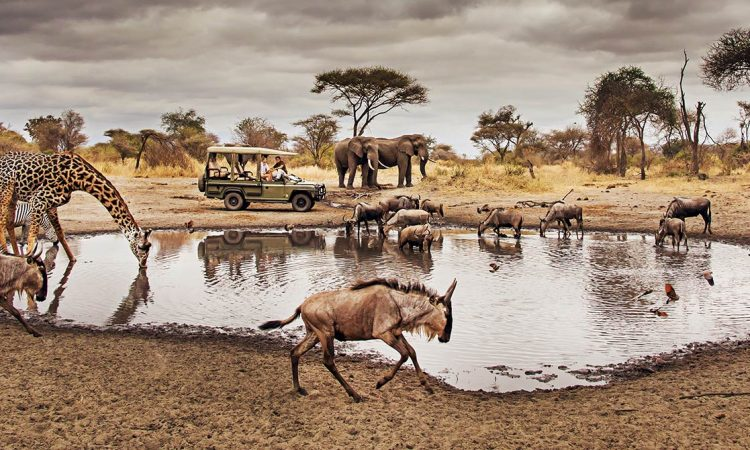Write a detailed description of the given image. This image captures a serene yet dynamic moment during a safari tour at the Serengeti National Park in Tanzania. The perspective is low, offering a ground-level view that makes the observer feel embedded in the scene. In the foreground, a variety of African wildlife gathers around a watering hole, an essential resource for their survival. A giraffe, towering as one of the tallest animals on Earth, seems curious about a nearby safari vehicle filled with tourists, possibly capturing the moment with cameras. To the left, a group of wildebeests is seen drinking water, their reflections shimmering on the surface of the watering hole. In the background, a couple of majestic elephants stand tall, adding to the grandeur of the landscape. The sky overhead is overcast with thick clouds, creating a dramatic contrast with the earthy tones of the savannah. The colors in the image mainly consist of browns, grays, and greens, seamlessly blending the natural elements together. Acacia trees dot the horizon, typical of the African savannah, and contribute to the authenticity of this breathtaking scene from the wild. 